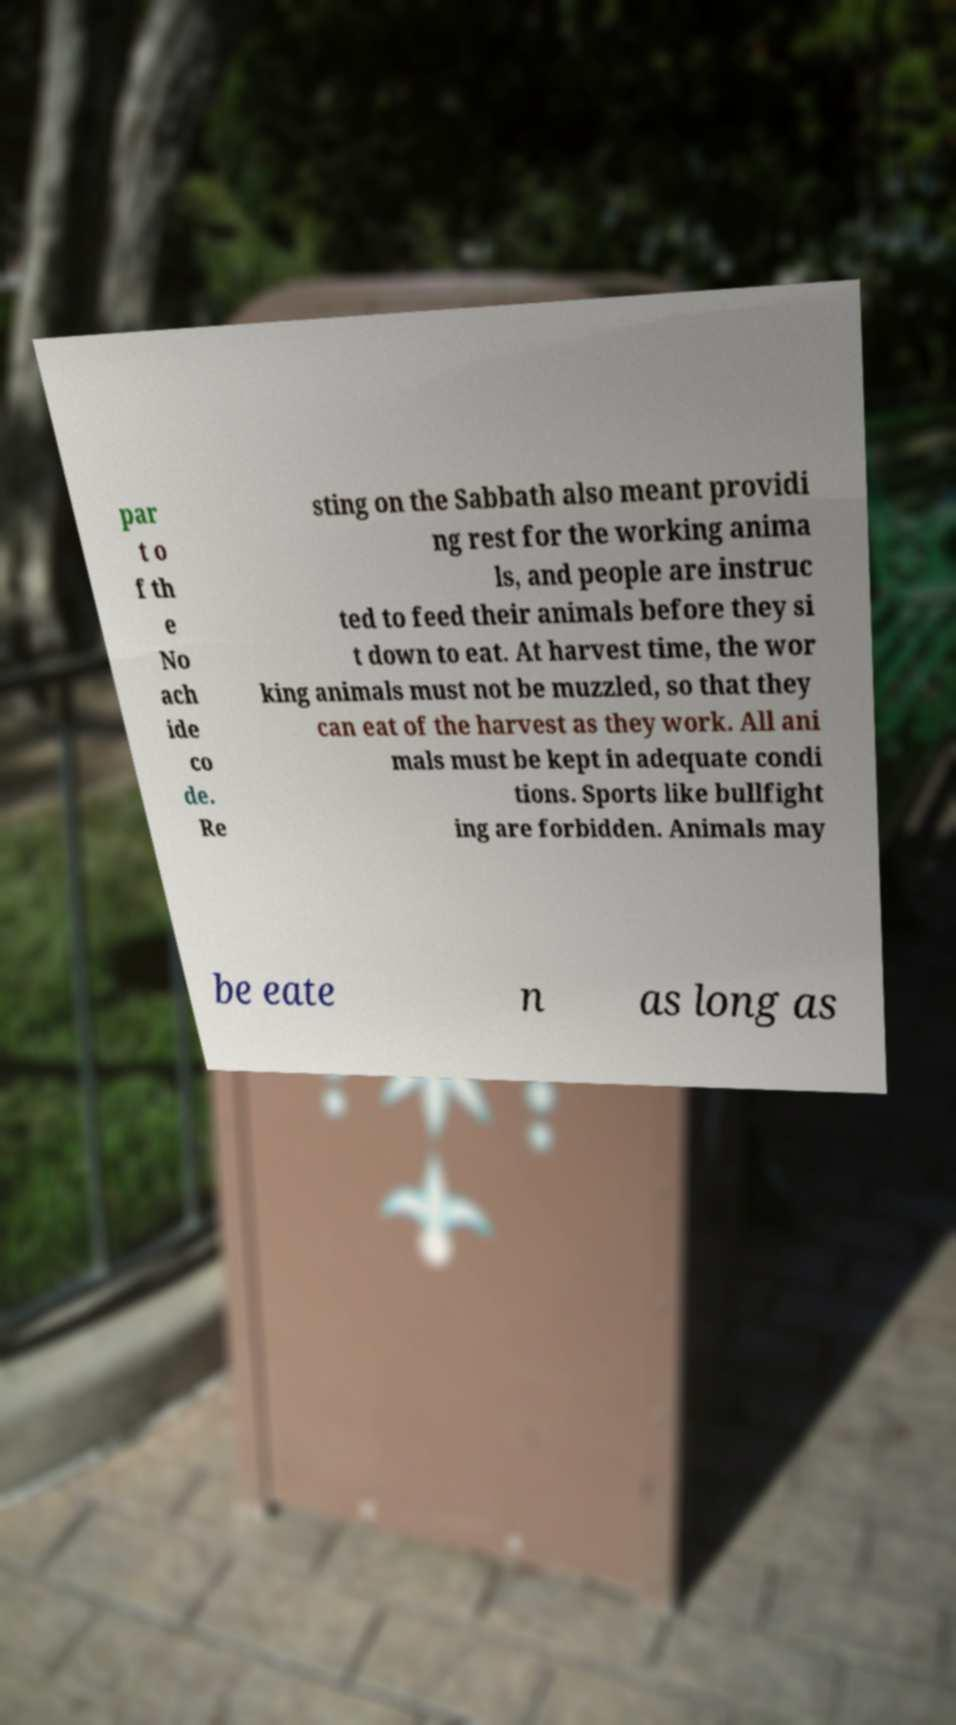Can you accurately transcribe the text from the provided image for me? par t o f th e No ach ide co de. Re sting on the Sabbath also meant providi ng rest for the working anima ls, and people are instruc ted to feed their animals before they si t down to eat. At harvest time, the wor king animals must not be muzzled, so that they can eat of the harvest as they work. All ani mals must be kept in adequate condi tions. Sports like bullfight ing are forbidden. Animals may be eate n as long as 